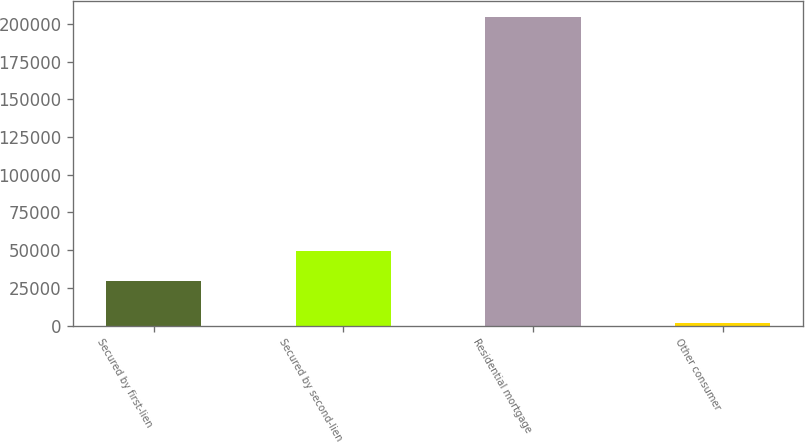<chart> <loc_0><loc_0><loc_500><loc_500><bar_chart><fcel>Secured by first-lien<fcel>Secured by second-lien<fcel>Residential mortgage<fcel>Other consumer<nl><fcel>29259<fcel>49525<fcel>204648<fcel>1988<nl></chart> 